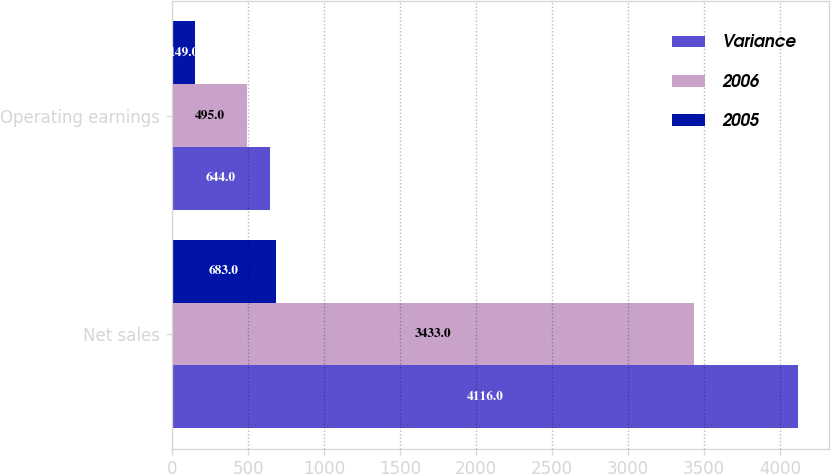<chart> <loc_0><loc_0><loc_500><loc_500><stacked_bar_chart><ecel><fcel>Net sales<fcel>Operating earnings<nl><fcel>Variance<fcel>4116<fcel>644<nl><fcel>2006<fcel>3433<fcel>495<nl><fcel>2005<fcel>683<fcel>149<nl></chart> 